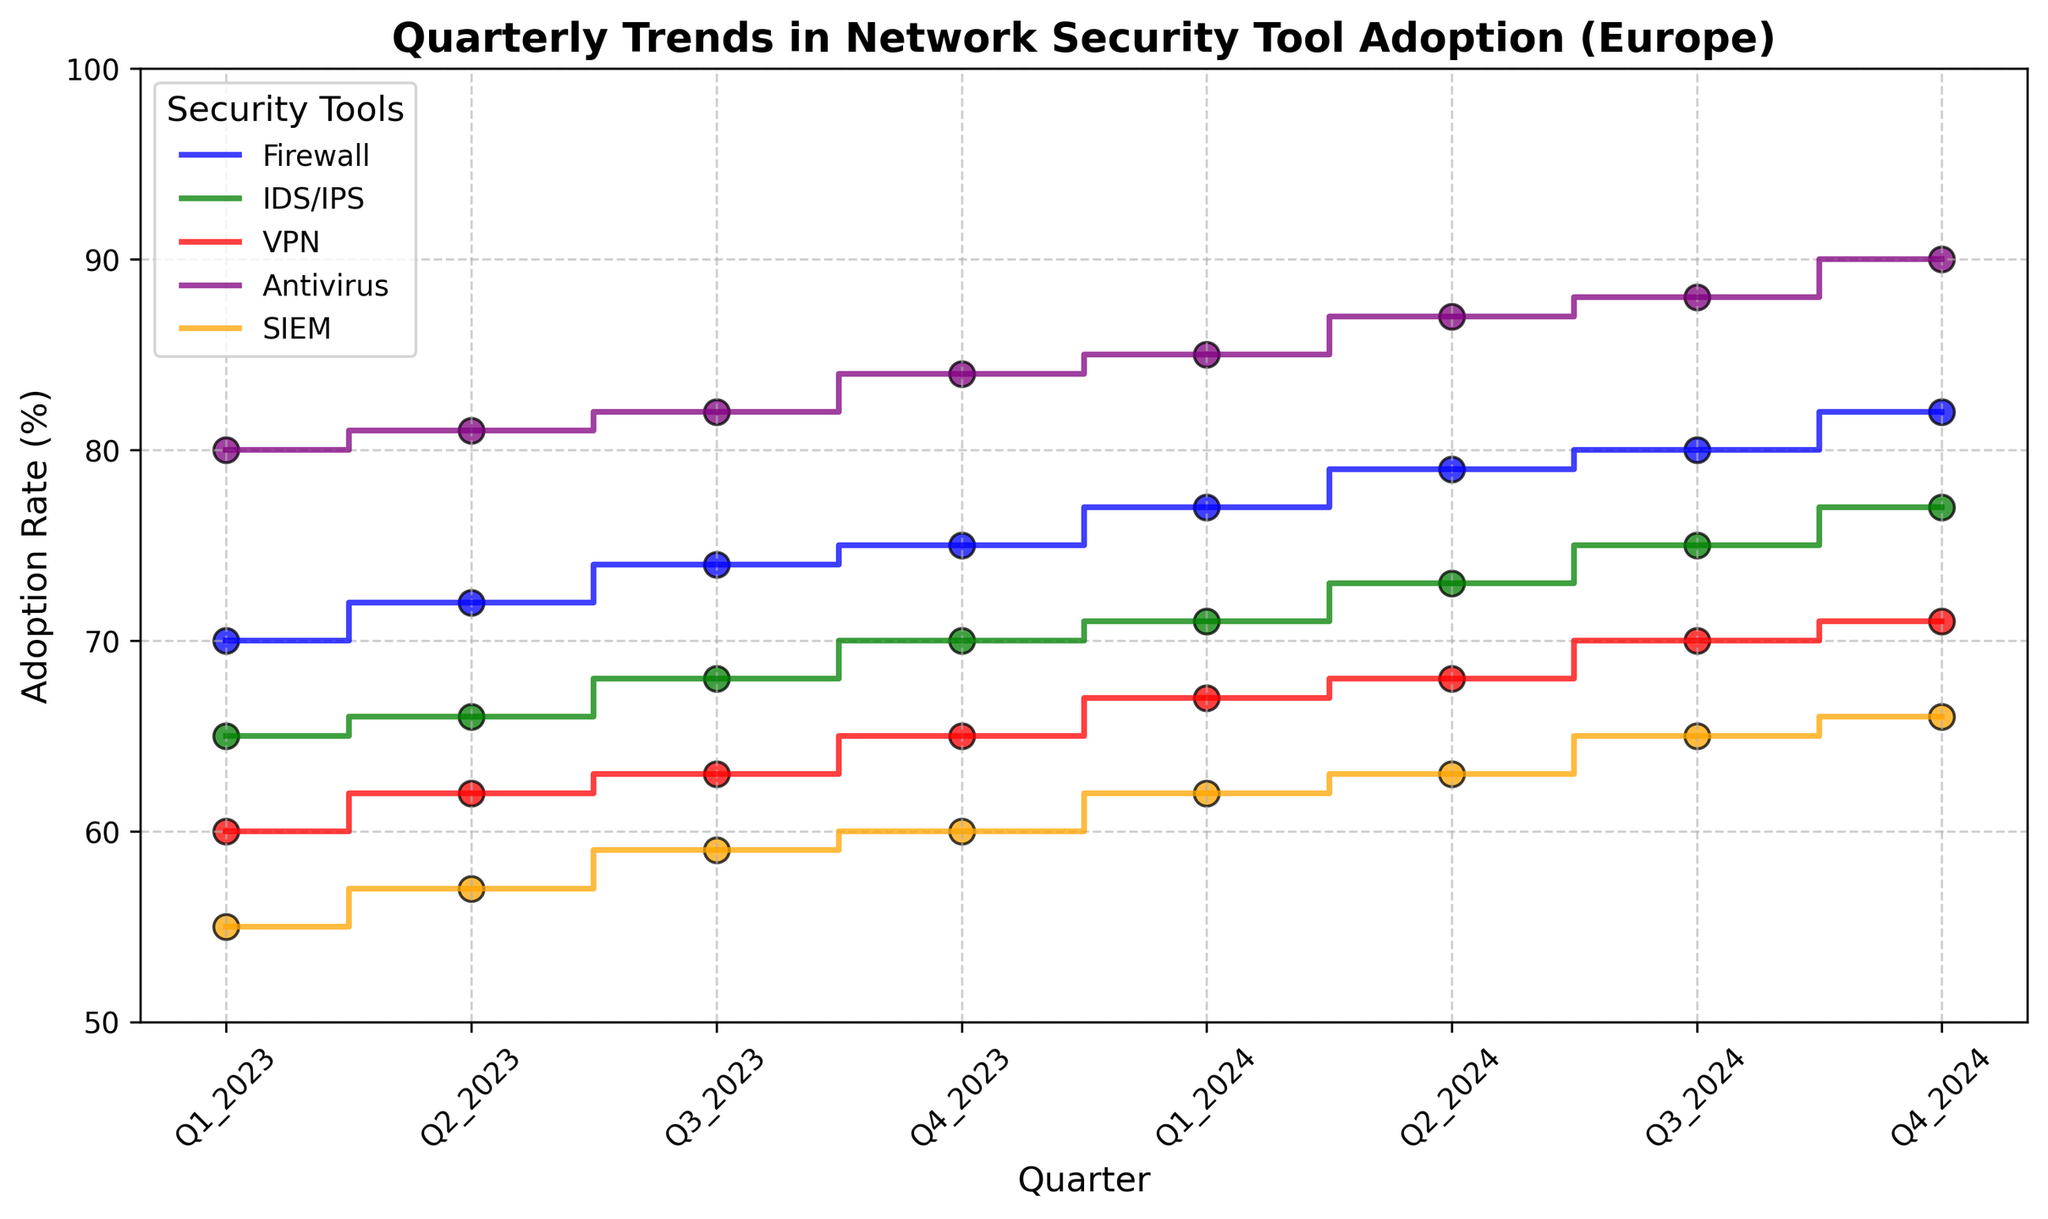What's the trend of Firewall adoption in Europe over the quarters displayed? The blue line in the plot represents the Firewall adoption rates in Europe. We observe that the adoption rate starts at 70% in Q1 2023 and ends at 82% in Q4 2024. The trend shows a steady increase in adoption rate across each quarter. Overall, the Firewall adoption rate in Europe shows an upward trend.
Answer: Upward trend Which security tool has the highest adoption rate in Q4 2024 in Europe? The plot shows that the Antivirus tool (represented in purple) peaks at 90% in Q4 2024, which is the highest adoption rate among all the tools in Europe at that time.
Answer: Antivirus Compare the adoption rates of the SIEM tool and the VPN tool in Europe in Q2 2024. Which one is higher and by how much percentage? In Q2 2024, the SIEM tool (orange line) has an adoption rate of 63%, and the VPN tool (red line) has an adoption rate of 68%. Therefore, the VPN tool has a higher adoption rate by (68% - 63%) 5 percentage points.
Answer: VPN by 5% What is the average adoption rate of IDS/IPS in Europe from Q1 2023 to Q4 2024? To find the average adoption rate for IDS/IPS over the specified quarters, sum up the rates from all quarters and divide by the number of quarters. Rates: 65, 66, 68, 70, 71, 73, 75, 77. Sum = 565. Average = 565 / 8 = 70.63%.
Answer: 70.63% Which tool showed the least variability in its adoption rates across the quarters in Europe? Variability can be gauged by observing the fluctuations in the stair plot lines. The Firewall and Antivirus tools show gradual increases with minor fluctuations. For more precision, let's compute the range (max-min) for each tool:
- Firewall: 82 - 70 = 12
- IDS/IPS: 77 - 65 = 12
- VPN: 71 - 60 = 11
- Antivirus: 90 - 80 = 10
- SIEM: 66 - 55 = 11
The Antivirus tool, with a range of 10, shows the least variability.
Answer: Antivirus How much did the adoption rate for Antivirus increase from Q1 2023 to Q2 2023 in Europe? From the plot, the Antivirus adoption rate in Q1 2023 is 80% and in Q2 2023 is 81%. The increase is calculated as 81% - 80% = 1%.
Answer: 1% Between Q4 2023 and Q1 2024, which network security tool saw the largest increase in adoption rate in Europe, and what was the increase? Observing the plot, we will compare the increments:
- Firewall: 77% to 79% = 2%
- IDS/IPS: 70% to 71% = 1%
- VPN: 65% to 67% = 2%
- Antivirus: 84% to 85% = 1%
- SIEM: 60% to 62% = 2%
Three tools (Firewall, VPN, and SIEM) saw the largest increment of 2%, tied for the highest increase during that period.
Answer: Firewall, VPN, SIEM by 2% 